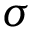<formula> <loc_0><loc_0><loc_500><loc_500>\sigma</formula> 